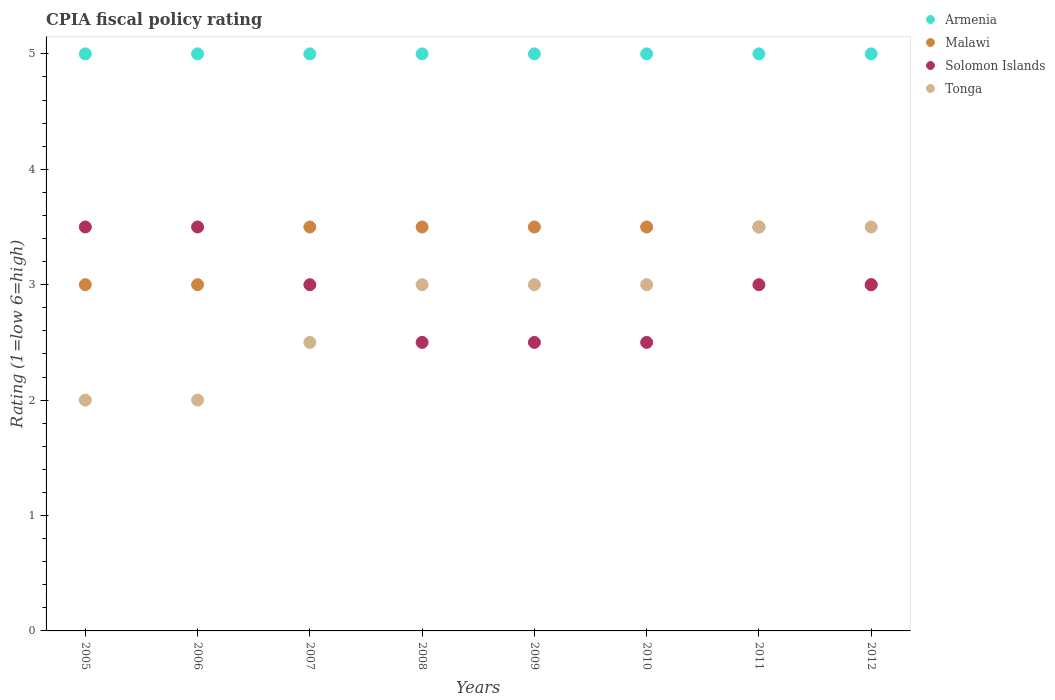What is the CPIA rating in Armenia in 2011?
Your response must be concise. 5. Across all years, what is the minimum CPIA rating in Malawi?
Give a very brief answer. 3. In which year was the CPIA rating in Malawi maximum?
Give a very brief answer. 2007. In which year was the CPIA rating in Armenia minimum?
Ensure brevity in your answer.  2005. What is the difference between the CPIA rating in Malawi in 2009 and the CPIA rating in Armenia in 2012?
Your answer should be compact. -1.5. What is the ratio of the CPIA rating in Malawi in 2008 to that in 2012?
Offer a terse response. 1.17. Is the CPIA rating in Tonga in 2005 less than that in 2011?
Give a very brief answer. Yes. What is the difference between the highest and the lowest CPIA rating in Armenia?
Give a very brief answer. 0. Is it the case that in every year, the sum of the CPIA rating in Solomon Islands and CPIA rating in Tonga  is greater than the CPIA rating in Malawi?
Keep it short and to the point. Yes. Does the CPIA rating in Armenia monotonically increase over the years?
Provide a short and direct response. No. Is the CPIA rating in Armenia strictly less than the CPIA rating in Malawi over the years?
Provide a short and direct response. No. Are the values on the major ticks of Y-axis written in scientific E-notation?
Provide a succinct answer. No. How many legend labels are there?
Make the answer very short. 4. What is the title of the graph?
Make the answer very short. CPIA fiscal policy rating. Does "Bangladesh" appear as one of the legend labels in the graph?
Your answer should be compact. No. What is the label or title of the X-axis?
Give a very brief answer. Years. What is the label or title of the Y-axis?
Offer a very short reply. Rating (1=low 6=high). What is the Rating (1=low 6=high) of Armenia in 2005?
Ensure brevity in your answer.  5. What is the Rating (1=low 6=high) in Malawi in 2005?
Ensure brevity in your answer.  3. What is the Rating (1=low 6=high) in Solomon Islands in 2005?
Your answer should be compact. 3.5. What is the Rating (1=low 6=high) of Tonga in 2005?
Your response must be concise. 2. What is the Rating (1=low 6=high) in Armenia in 2006?
Keep it short and to the point. 5. What is the Rating (1=low 6=high) in Solomon Islands in 2006?
Give a very brief answer. 3.5. What is the Rating (1=low 6=high) of Malawi in 2007?
Keep it short and to the point. 3.5. What is the Rating (1=low 6=high) in Tonga in 2007?
Your answer should be very brief. 2.5. What is the Rating (1=low 6=high) of Malawi in 2008?
Your response must be concise. 3.5. What is the Rating (1=low 6=high) in Solomon Islands in 2008?
Your answer should be compact. 2.5. What is the Rating (1=low 6=high) in Malawi in 2009?
Give a very brief answer. 3.5. What is the Rating (1=low 6=high) in Tonga in 2009?
Keep it short and to the point. 3. What is the Rating (1=low 6=high) in Malawi in 2010?
Your answer should be very brief. 3.5. What is the Rating (1=low 6=high) of Solomon Islands in 2011?
Your answer should be very brief. 3. What is the Rating (1=low 6=high) in Armenia in 2012?
Your response must be concise. 5. What is the Rating (1=low 6=high) in Malawi in 2012?
Offer a terse response. 3. What is the Rating (1=low 6=high) in Tonga in 2012?
Ensure brevity in your answer.  3.5. Across all years, what is the maximum Rating (1=low 6=high) in Malawi?
Provide a short and direct response. 3.5. Across all years, what is the maximum Rating (1=low 6=high) of Solomon Islands?
Offer a terse response. 3.5. Across all years, what is the minimum Rating (1=low 6=high) of Malawi?
Your response must be concise. 3. Across all years, what is the minimum Rating (1=low 6=high) in Solomon Islands?
Your response must be concise. 2.5. What is the total Rating (1=low 6=high) in Tonga in the graph?
Your answer should be compact. 22.5. What is the difference between the Rating (1=low 6=high) of Armenia in 2005 and that in 2006?
Offer a terse response. 0. What is the difference between the Rating (1=low 6=high) of Malawi in 2005 and that in 2006?
Your answer should be compact. 0. What is the difference between the Rating (1=low 6=high) of Armenia in 2005 and that in 2007?
Provide a short and direct response. 0. What is the difference between the Rating (1=low 6=high) in Malawi in 2005 and that in 2007?
Provide a succinct answer. -0.5. What is the difference between the Rating (1=low 6=high) of Solomon Islands in 2005 and that in 2007?
Keep it short and to the point. 0.5. What is the difference between the Rating (1=low 6=high) in Tonga in 2005 and that in 2007?
Offer a very short reply. -0.5. What is the difference between the Rating (1=low 6=high) of Armenia in 2005 and that in 2008?
Offer a terse response. 0. What is the difference between the Rating (1=low 6=high) of Solomon Islands in 2005 and that in 2008?
Ensure brevity in your answer.  1. What is the difference between the Rating (1=low 6=high) of Malawi in 2005 and that in 2009?
Your response must be concise. -0.5. What is the difference between the Rating (1=low 6=high) of Armenia in 2005 and that in 2010?
Keep it short and to the point. 0. What is the difference between the Rating (1=low 6=high) of Armenia in 2005 and that in 2011?
Make the answer very short. 0. What is the difference between the Rating (1=low 6=high) in Malawi in 2005 and that in 2011?
Your answer should be very brief. -0.5. What is the difference between the Rating (1=low 6=high) in Solomon Islands in 2005 and that in 2011?
Offer a terse response. 0.5. What is the difference between the Rating (1=low 6=high) of Armenia in 2005 and that in 2012?
Offer a terse response. 0. What is the difference between the Rating (1=low 6=high) of Solomon Islands in 2005 and that in 2012?
Keep it short and to the point. 0.5. What is the difference between the Rating (1=low 6=high) in Tonga in 2005 and that in 2012?
Provide a short and direct response. -1.5. What is the difference between the Rating (1=low 6=high) of Malawi in 2006 and that in 2007?
Your response must be concise. -0.5. What is the difference between the Rating (1=low 6=high) of Tonga in 2006 and that in 2007?
Make the answer very short. -0.5. What is the difference between the Rating (1=low 6=high) of Armenia in 2006 and that in 2008?
Your response must be concise. 0. What is the difference between the Rating (1=low 6=high) in Malawi in 2006 and that in 2008?
Give a very brief answer. -0.5. What is the difference between the Rating (1=low 6=high) in Solomon Islands in 2006 and that in 2008?
Make the answer very short. 1. What is the difference between the Rating (1=low 6=high) of Tonga in 2006 and that in 2008?
Your answer should be compact. -1. What is the difference between the Rating (1=low 6=high) of Armenia in 2006 and that in 2009?
Provide a succinct answer. 0. What is the difference between the Rating (1=low 6=high) of Malawi in 2006 and that in 2009?
Provide a succinct answer. -0.5. What is the difference between the Rating (1=low 6=high) of Armenia in 2006 and that in 2010?
Your answer should be compact. 0. What is the difference between the Rating (1=low 6=high) in Malawi in 2006 and that in 2010?
Your response must be concise. -0.5. What is the difference between the Rating (1=low 6=high) of Tonga in 2006 and that in 2010?
Offer a terse response. -1. What is the difference between the Rating (1=low 6=high) of Malawi in 2006 and that in 2011?
Offer a very short reply. -0.5. What is the difference between the Rating (1=low 6=high) in Solomon Islands in 2006 and that in 2011?
Provide a short and direct response. 0.5. What is the difference between the Rating (1=low 6=high) of Armenia in 2006 and that in 2012?
Make the answer very short. 0. What is the difference between the Rating (1=low 6=high) in Armenia in 2007 and that in 2008?
Provide a short and direct response. 0. What is the difference between the Rating (1=low 6=high) in Malawi in 2007 and that in 2008?
Provide a short and direct response. 0. What is the difference between the Rating (1=low 6=high) of Armenia in 2007 and that in 2009?
Keep it short and to the point. 0. What is the difference between the Rating (1=low 6=high) in Malawi in 2007 and that in 2009?
Provide a succinct answer. 0. What is the difference between the Rating (1=low 6=high) in Solomon Islands in 2007 and that in 2009?
Your response must be concise. 0.5. What is the difference between the Rating (1=low 6=high) of Malawi in 2007 and that in 2010?
Your response must be concise. 0. What is the difference between the Rating (1=low 6=high) in Solomon Islands in 2007 and that in 2010?
Provide a succinct answer. 0.5. What is the difference between the Rating (1=low 6=high) in Armenia in 2007 and that in 2011?
Provide a succinct answer. 0. What is the difference between the Rating (1=low 6=high) of Malawi in 2007 and that in 2011?
Your answer should be very brief. 0. What is the difference between the Rating (1=low 6=high) in Tonga in 2007 and that in 2011?
Give a very brief answer. -1. What is the difference between the Rating (1=low 6=high) in Solomon Islands in 2007 and that in 2012?
Offer a terse response. 0. What is the difference between the Rating (1=low 6=high) of Tonga in 2007 and that in 2012?
Make the answer very short. -1. What is the difference between the Rating (1=low 6=high) of Malawi in 2008 and that in 2009?
Your answer should be compact. 0. What is the difference between the Rating (1=low 6=high) of Tonga in 2008 and that in 2009?
Your answer should be very brief. 0. What is the difference between the Rating (1=low 6=high) of Armenia in 2008 and that in 2010?
Your answer should be very brief. 0. What is the difference between the Rating (1=low 6=high) of Malawi in 2008 and that in 2010?
Ensure brevity in your answer.  0. What is the difference between the Rating (1=low 6=high) in Tonga in 2008 and that in 2010?
Offer a very short reply. 0. What is the difference between the Rating (1=low 6=high) in Solomon Islands in 2008 and that in 2011?
Ensure brevity in your answer.  -0.5. What is the difference between the Rating (1=low 6=high) of Armenia in 2008 and that in 2012?
Offer a very short reply. 0. What is the difference between the Rating (1=low 6=high) in Malawi in 2008 and that in 2012?
Make the answer very short. 0.5. What is the difference between the Rating (1=low 6=high) in Tonga in 2008 and that in 2012?
Offer a very short reply. -0.5. What is the difference between the Rating (1=low 6=high) of Solomon Islands in 2009 and that in 2010?
Your answer should be very brief. 0. What is the difference between the Rating (1=low 6=high) of Armenia in 2009 and that in 2011?
Your answer should be very brief. 0. What is the difference between the Rating (1=low 6=high) of Malawi in 2009 and that in 2011?
Your response must be concise. 0. What is the difference between the Rating (1=low 6=high) of Solomon Islands in 2009 and that in 2012?
Give a very brief answer. -0.5. What is the difference between the Rating (1=low 6=high) of Armenia in 2010 and that in 2011?
Your response must be concise. 0. What is the difference between the Rating (1=low 6=high) in Malawi in 2010 and that in 2011?
Provide a short and direct response. 0. What is the difference between the Rating (1=low 6=high) of Armenia in 2010 and that in 2012?
Offer a very short reply. 0. What is the difference between the Rating (1=low 6=high) of Malawi in 2010 and that in 2012?
Your response must be concise. 0.5. What is the difference between the Rating (1=low 6=high) in Solomon Islands in 2010 and that in 2012?
Your response must be concise. -0.5. What is the difference between the Rating (1=low 6=high) of Malawi in 2011 and that in 2012?
Provide a succinct answer. 0.5. What is the difference between the Rating (1=low 6=high) in Solomon Islands in 2011 and that in 2012?
Ensure brevity in your answer.  0. What is the difference between the Rating (1=low 6=high) in Tonga in 2011 and that in 2012?
Give a very brief answer. 0. What is the difference between the Rating (1=low 6=high) of Armenia in 2005 and the Rating (1=low 6=high) of Malawi in 2006?
Keep it short and to the point. 2. What is the difference between the Rating (1=low 6=high) of Armenia in 2005 and the Rating (1=low 6=high) of Tonga in 2006?
Provide a short and direct response. 3. What is the difference between the Rating (1=low 6=high) in Armenia in 2005 and the Rating (1=low 6=high) in Malawi in 2007?
Provide a short and direct response. 1.5. What is the difference between the Rating (1=low 6=high) of Armenia in 2005 and the Rating (1=low 6=high) of Solomon Islands in 2007?
Your response must be concise. 2. What is the difference between the Rating (1=low 6=high) in Solomon Islands in 2005 and the Rating (1=low 6=high) in Tonga in 2007?
Make the answer very short. 1. What is the difference between the Rating (1=low 6=high) in Armenia in 2005 and the Rating (1=low 6=high) in Solomon Islands in 2008?
Your answer should be very brief. 2.5. What is the difference between the Rating (1=low 6=high) in Armenia in 2005 and the Rating (1=low 6=high) in Tonga in 2008?
Your response must be concise. 2. What is the difference between the Rating (1=low 6=high) of Malawi in 2005 and the Rating (1=low 6=high) of Solomon Islands in 2008?
Give a very brief answer. 0.5. What is the difference between the Rating (1=low 6=high) in Armenia in 2005 and the Rating (1=low 6=high) in Malawi in 2009?
Your answer should be compact. 1.5. What is the difference between the Rating (1=low 6=high) of Armenia in 2005 and the Rating (1=low 6=high) of Solomon Islands in 2009?
Your response must be concise. 2.5. What is the difference between the Rating (1=low 6=high) of Armenia in 2005 and the Rating (1=low 6=high) of Tonga in 2009?
Give a very brief answer. 2. What is the difference between the Rating (1=low 6=high) of Armenia in 2005 and the Rating (1=low 6=high) of Solomon Islands in 2010?
Provide a short and direct response. 2.5. What is the difference between the Rating (1=low 6=high) of Armenia in 2005 and the Rating (1=low 6=high) of Tonga in 2010?
Provide a short and direct response. 2. What is the difference between the Rating (1=low 6=high) in Armenia in 2005 and the Rating (1=low 6=high) in Tonga in 2011?
Offer a very short reply. 1.5. What is the difference between the Rating (1=low 6=high) of Malawi in 2005 and the Rating (1=low 6=high) of Solomon Islands in 2011?
Give a very brief answer. 0. What is the difference between the Rating (1=low 6=high) of Malawi in 2005 and the Rating (1=low 6=high) of Tonga in 2011?
Offer a terse response. -0.5. What is the difference between the Rating (1=low 6=high) of Armenia in 2005 and the Rating (1=low 6=high) of Malawi in 2012?
Provide a succinct answer. 2. What is the difference between the Rating (1=low 6=high) in Malawi in 2005 and the Rating (1=low 6=high) in Solomon Islands in 2012?
Offer a terse response. 0. What is the difference between the Rating (1=low 6=high) of Malawi in 2005 and the Rating (1=low 6=high) of Tonga in 2012?
Provide a short and direct response. -0.5. What is the difference between the Rating (1=low 6=high) in Solomon Islands in 2005 and the Rating (1=low 6=high) in Tonga in 2012?
Offer a terse response. 0. What is the difference between the Rating (1=low 6=high) in Armenia in 2006 and the Rating (1=low 6=high) in Malawi in 2007?
Your response must be concise. 1.5. What is the difference between the Rating (1=low 6=high) in Malawi in 2006 and the Rating (1=low 6=high) in Solomon Islands in 2007?
Ensure brevity in your answer.  0. What is the difference between the Rating (1=low 6=high) in Malawi in 2006 and the Rating (1=low 6=high) in Tonga in 2008?
Provide a short and direct response. 0. What is the difference between the Rating (1=low 6=high) of Armenia in 2006 and the Rating (1=low 6=high) of Malawi in 2009?
Keep it short and to the point. 1.5. What is the difference between the Rating (1=low 6=high) of Armenia in 2006 and the Rating (1=low 6=high) of Solomon Islands in 2009?
Offer a very short reply. 2.5. What is the difference between the Rating (1=low 6=high) of Armenia in 2006 and the Rating (1=low 6=high) of Tonga in 2009?
Ensure brevity in your answer.  2. What is the difference between the Rating (1=low 6=high) of Armenia in 2006 and the Rating (1=low 6=high) of Malawi in 2010?
Provide a short and direct response. 1.5. What is the difference between the Rating (1=low 6=high) of Armenia in 2006 and the Rating (1=low 6=high) of Solomon Islands in 2010?
Give a very brief answer. 2.5. What is the difference between the Rating (1=low 6=high) of Solomon Islands in 2006 and the Rating (1=low 6=high) of Tonga in 2010?
Offer a very short reply. 0.5. What is the difference between the Rating (1=low 6=high) in Armenia in 2006 and the Rating (1=low 6=high) in Malawi in 2011?
Ensure brevity in your answer.  1.5. What is the difference between the Rating (1=low 6=high) in Armenia in 2006 and the Rating (1=low 6=high) in Solomon Islands in 2011?
Your answer should be very brief. 2. What is the difference between the Rating (1=low 6=high) of Malawi in 2006 and the Rating (1=low 6=high) of Solomon Islands in 2011?
Your response must be concise. 0. What is the difference between the Rating (1=low 6=high) in Malawi in 2006 and the Rating (1=low 6=high) in Tonga in 2011?
Keep it short and to the point. -0.5. What is the difference between the Rating (1=low 6=high) of Solomon Islands in 2006 and the Rating (1=low 6=high) of Tonga in 2011?
Make the answer very short. 0. What is the difference between the Rating (1=low 6=high) in Armenia in 2006 and the Rating (1=low 6=high) in Malawi in 2012?
Your answer should be compact. 2. What is the difference between the Rating (1=low 6=high) of Armenia in 2007 and the Rating (1=low 6=high) of Malawi in 2008?
Make the answer very short. 1.5. What is the difference between the Rating (1=low 6=high) of Armenia in 2007 and the Rating (1=low 6=high) of Solomon Islands in 2008?
Your response must be concise. 2.5. What is the difference between the Rating (1=low 6=high) in Solomon Islands in 2007 and the Rating (1=low 6=high) in Tonga in 2008?
Give a very brief answer. 0. What is the difference between the Rating (1=low 6=high) in Armenia in 2007 and the Rating (1=low 6=high) in Solomon Islands in 2009?
Keep it short and to the point. 2.5. What is the difference between the Rating (1=low 6=high) of Solomon Islands in 2007 and the Rating (1=low 6=high) of Tonga in 2009?
Offer a terse response. 0. What is the difference between the Rating (1=low 6=high) of Armenia in 2007 and the Rating (1=low 6=high) of Malawi in 2010?
Your response must be concise. 1.5. What is the difference between the Rating (1=low 6=high) in Malawi in 2007 and the Rating (1=low 6=high) in Solomon Islands in 2010?
Give a very brief answer. 1. What is the difference between the Rating (1=low 6=high) of Malawi in 2007 and the Rating (1=low 6=high) of Tonga in 2010?
Offer a very short reply. 0.5. What is the difference between the Rating (1=low 6=high) in Solomon Islands in 2007 and the Rating (1=low 6=high) in Tonga in 2010?
Offer a terse response. 0. What is the difference between the Rating (1=low 6=high) of Armenia in 2007 and the Rating (1=low 6=high) of Tonga in 2011?
Your answer should be compact. 1.5. What is the difference between the Rating (1=low 6=high) in Malawi in 2007 and the Rating (1=low 6=high) in Tonga in 2011?
Make the answer very short. 0. What is the difference between the Rating (1=low 6=high) of Solomon Islands in 2007 and the Rating (1=low 6=high) of Tonga in 2011?
Your answer should be compact. -0.5. What is the difference between the Rating (1=low 6=high) in Armenia in 2007 and the Rating (1=low 6=high) in Solomon Islands in 2012?
Your answer should be very brief. 2. What is the difference between the Rating (1=low 6=high) of Armenia in 2007 and the Rating (1=low 6=high) of Tonga in 2012?
Make the answer very short. 1.5. What is the difference between the Rating (1=low 6=high) in Malawi in 2007 and the Rating (1=low 6=high) in Solomon Islands in 2012?
Make the answer very short. 0.5. What is the difference between the Rating (1=low 6=high) in Malawi in 2007 and the Rating (1=low 6=high) in Tonga in 2012?
Provide a short and direct response. 0. What is the difference between the Rating (1=low 6=high) in Solomon Islands in 2007 and the Rating (1=low 6=high) in Tonga in 2012?
Give a very brief answer. -0.5. What is the difference between the Rating (1=low 6=high) of Armenia in 2008 and the Rating (1=low 6=high) of Malawi in 2009?
Offer a very short reply. 1.5. What is the difference between the Rating (1=low 6=high) of Malawi in 2008 and the Rating (1=low 6=high) of Tonga in 2009?
Keep it short and to the point. 0.5. What is the difference between the Rating (1=low 6=high) of Solomon Islands in 2008 and the Rating (1=low 6=high) of Tonga in 2009?
Give a very brief answer. -0.5. What is the difference between the Rating (1=low 6=high) of Armenia in 2008 and the Rating (1=low 6=high) of Malawi in 2010?
Keep it short and to the point. 1.5. What is the difference between the Rating (1=low 6=high) of Armenia in 2008 and the Rating (1=low 6=high) of Solomon Islands in 2010?
Your answer should be very brief. 2.5. What is the difference between the Rating (1=low 6=high) of Malawi in 2008 and the Rating (1=low 6=high) of Tonga in 2010?
Give a very brief answer. 0.5. What is the difference between the Rating (1=low 6=high) in Armenia in 2008 and the Rating (1=low 6=high) in Malawi in 2011?
Keep it short and to the point. 1.5. What is the difference between the Rating (1=low 6=high) of Malawi in 2008 and the Rating (1=low 6=high) of Tonga in 2011?
Offer a very short reply. 0. What is the difference between the Rating (1=low 6=high) in Solomon Islands in 2008 and the Rating (1=low 6=high) in Tonga in 2011?
Offer a very short reply. -1. What is the difference between the Rating (1=low 6=high) in Armenia in 2008 and the Rating (1=low 6=high) in Malawi in 2012?
Offer a terse response. 2. What is the difference between the Rating (1=low 6=high) of Armenia in 2008 and the Rating (1=low 6=high) of Tonga in 2012?
Your answer should be very brief. 1.5. What is the difference between the Rating (1=low 6=high) in Malawi in 2008 and the Rating (1=low 6=high) in Solomon Islands in 2012?
Your response must be concise. 0.5. What is the difference between the Rating (1=low 6=high) of Malawi in 2008 and the Rating (1=low 6=high) of Tonga in 2012?
Make the answer very short. 0. What is the difference between the Rating (1=low 6=high) of Solomon Islands in 2008 and the Rating (1=low 6=high) of Tonga in 2012?
Ensure brevity in your answer.  -1. What is the difference between the Rating (1=low 6=high) of Armenia in 2009 and the Rating (1=low 6=high) of Malawi in 2010?
Provide a short and direct response. 1.5. What is the difference between the Rating (1=low 6=high) of Armenia in 2009 and the Rating (1=low 6=high) of Solomon Islands in 2010?
Keep it short and to the point. 2.5. What is the difference between the Rating (1=low 6=high) in Armenia in 2009 and the Rating (1=low 6=high) in Tonga in 2010?
Keep it short and to the point. 2. What is the difference between the Rating (1=low 6=high) of Malawi in 2009 and the Rating (1=low 6=high) of Solomon Islands in 2010?
Offer a very short reply. 1. What is the difference between the Rating (1=low 6=high) in Malawi in 2009 and the Rating (1=low 6=high) in Tonga in 2010?
Offer a very short reply. 0.5. What is the difference between the Rating (1=low 6=high) in Armenia in 2009 and the Rating (1=low 6=high) in Solomon Islands in 2011?
Provide a succinct answer. 2. What is the difference between the Rating (1=low 6=high) in Armenia in 2009 and the Rating (1=low 6=high) in Tonga in 2011?
Give a very brief answer. 1.5. What is the difference between the Rating (1=low 6=high) of Malawi in 2009 and the Rating (1=low 6=high) of Tonga in 2011?
Ensure brevity in your answer.  0. What is the difference between the Rating (1=low 6=high) of Solomon Islands in 2009 and the Rating (1=low 6=high) of Tonga in 2011?
Offer a terse response. -1. What is the difference between the Rating (1=low 6=high) of Armenia in 2009 and the Rating (1=low 6=high) of Malawi in 2012?
Provide a succinct answer. 2. What is the difference between the Rating (1=low 6=high) of Solomon Islands in 2009 and the Rating (1=low 6=high) of Tonga in 2012?
Your response must be concise. -1. What is the difference between the Rating (1=low 6=high) in Armenia in 2010 and the Rating (1=low 6=high) in Tonga in 2011?
Provide a short and direct response. 1.5. What is the difference between the Rating (1=low 6=high) in Malawi in 2010 and the Rating (1=low 6=high) in Solomon Islands in 2011?
Keep it short and to the point. 0.5. What is the difference between the Rating (1=low 6=high) of Malawi in 2010 and the Rating (1=low 6=high) of Tonga in 2011?
Offer a very short reply. 0. What is the difference between the Rating (1=low 6=high) of Armenia in 2010 and the Rating (1=low 6=high) of Malawi in 2012?
Give a very brief answer. 2. What is the difference between the Rating (1=low 6=high) of Armenia in 2010 and the Rating (1=low 6=high) of Tonga in 2012?
Give a very brief answer. 1.5. What is the difference between the Rating (1=low 6=high) of Malawi in 2010 and the Rating (1=low 6=high) of Solomon Islands in 2012?
Your answer should be compact. 0.5. What is the difference between the Rating (1=low 6=high) in Malawi in 2010 and the Rating (1=low 6=high) in Tonga in 2012?
Give a very brief answer. 0. What is the difference between the Rating (1=low 6=high) in Solomon Islands in 2010 and the Rating (1=low 6=high) in Tonga in 2012?
Your answer should be very brief. -1. What is the difference between the Rating (1=low 6=high) of Armenia in 2011 and the Rating (1=low 6=high) of Tonga in 2012?
Offer a terse response. 1.5. What is the difference between the Rating (1=low 6=high) of Malawi in 2011 and the Rating (1=low 6=high) of Tonga in 2012?
Your answer should be very brief. 0. What is the average Rating (1=low 6=high) in Armenia per year?
Keep it short and to the point. 5. What is the average Rating (1=low 6=high) in Malawi per year?
Provide a succinct answer. 3.31. What is the average Rating (1=low 6=high) of Solomon Islands per year?
Ensure brevity in your answer.  2.94. What is the average Rating (1=low 6=high) in Tonga per year?
Your answer should be compact. 2.81. In the year 2005, what is the difference between the Rating (1=low 6=high) in Armenia and Rating (1=low 6=high) in Malawi?
Make the answer very short. 2. In the year 2005, what is the difference between the Rating (1=low 6=high) in Armenia and Rating (1=low 6=high) in Solomon Islands?
Offer a very short reply. 1.5. In the year 2005, what is the difference between the Rating (1=low 6=high) in Armenia and Rating (1=low 6=high) in Tonga?
Your response must be concise. 3. In the year 2005, what is the difference between the Rating (1=low 6=high) in Solomon Islands and Rating (1=low 6=high) in Tonga?
Provide a succinct answer. 1.5. In the year 2006, what is the difference between the Rating (1=low 6=high) in Armenia and Rating (1=low 6=high) in Solomon Islands?
Ensure brevity in your answer.  1.5. In the year 2006, what is the difference between the Rating (1=low 6=high) of Solomon Islands and Rating (1=low 6=high) of Tonga?
Your answer should be very brief. 1.5. In the year 2007, what is the difference between the Rating (1=low 6=high) in Armenia and Rating (1=low 6=high) in Malawi?
Ensure brevity in your answer.  1.5. In the year 2007, what is the difference between the Rating (1=low 6=high) in Armenia and Rating (1=low 6=high) in Solomon Islands?
Provide a succinct answer. 2. In the year 2007, what is the difference between the Rating (1=low 6=high) in Solomon Islands and Rating (1=low 6=high) in Tonga?
Your answer should be compact. 0.5. In the year 2008, what is the difference between the Rating (1=low 6=high) of Malawi and Rating (1=low 6=high) of Solomon Islands?
Make the answer very short. 1. In the year 2008, what is the difference between the Rating (1=low 6=high) in Solomon Islands and Rating (1=low 6=high) in Tonga?
Offer a terse response. -0.5. In the year 2009, what is the difference between the Rating (1=low 6=high) in Armenia and Rating (1=low 6=high) in Malawi?
Ensure brevity in your answer.  1.5. In the year 2009, what is the difference between the Rating (1=low 6=high) of Malawi and Rating (1=low 6=high) of Solomon Islands?
Keep it short and to the point. 1. In the year 2009, what is the difference between the Rating (1=low 6=high) in Malawi and Rating (1=low 6=high) in Tonga?
Offer a terse response. 0.5. In the year 2009, what is the difference between the Rating (1=low 6=high) in Solomon Islands and Rating (1=low 6=high) in Tonga?
Your response must be concise. -0.5. In the year 2010, what is the difference between the Rating (1=low 6=high) of Armenia and Rating (1=low 6=high) of Malawi?
Provide a short and direct response. 1.5. In the year 2011, what is the difference between the Rating (1=low 6=high) in Armenia and Rating (1=low 6=high) in Malawi?
Offer a very short reply. 1.5. In the year 2011, what is the difference between the Rating (1=low 6=high) of Armenia and Rating (1=low 6=high) of Solomon Islands?
Ensure brevity in your answer.  2. In the year 2011, what is the difference between the Rating (1=low 6=high) of Armenia and Rating (1=low 6=high) of Tonga?
Give a very brief answer. 1.5. In the year 2011, what is the difference between the Rating (1=low 6=high) in Malawi and Rating (1=low 6=high) in Solomon Islands?
Your answer should be compact. 0.5. In the year 2012, what is the difference between the Rating (1=low 6=high) in Armenia and Rating (1=low 6=high) in Solomon Islands?
Ensure brevity in your answer.  2. In the year 2012, what is the difference between the Rating (1=low 6=high) of Armenia and Rating (1=low 6=high) of Tonga?
Ensure brevity in your answer.  1.5. What is the ratio of the Rating (1=low 6=high) of Armenia in 2005 to that in 2006?
Offer a very short reply. 1. What is the ratio of the Rating (1=low 6=high) in Solomon Islands in 2005 to that in 2006?
Your answer should be very brief. 1. What is the ratio of the Rating (1=low 6=high) of Tonga in 2005 to that in 2006?
Your response must be concise. 1. What is the ratio of the Rating (1=low 6=high) in Malawi in 2005 to that in 2007?
Give a very brief answer. 0.86. What is the ratio of the Rating (1=low 6=high) in Solomon Islands in 2005 to that in 2007?
Ensure brevity in your answer.  1.17. What is the ratio of the Rating (1=low 6=high) in Malawi in 2005 to that in 2008?
Offer a very short reply. 0.86. What is the ratio of the Rating (1=low 6=high) in Tonga in 2005 to that in 2008?
Ensure brevity in your answer.  0.67. What is the ratio of the Rating (1=low 6=high) in Armenia in 2005 to that in 2009?
Offer a terse response. 1. What is the ratio of the Rating (1=low 6=high) of Armenia in 2005 to that in 2010?
Provide a short and direct response. 1. What is the ratio of the Rating (1=low 6=high) of Malawi in 2005 to that in 2010?
Keep it short and to the point. 0.86. What is the ratio of the Rating (1=low 6=high) in Solomon Islands in 2005 to that in 2010?
Your response must be concise. 1.4. What is the ratio of the Rating (1=low 6=high) of Tonga in 2005 to that in 2010?
Your response must be concise. 0.67. What is the ratio of the Rating (1=low 6=high) in Armenia in 2005 to that in 2011?
Your answer should be compact. 1. What is the ratio of the Rating (1=low 6=high) of Solomon Islands in 2005 to that in 2012?
Your answer should be very brief. 1.17. What is the ratio of the Rating (1=low 6=high) of Tonga in 2005 to that in 2012?
Make the answer very short. 0.57. What is the ratio of the Rating (1=low 6=high) of Malawi in 2006 to that in 2007?
Offer a terse response. 0.86. What is the ratio of the Rating (1=low 6=high) of Solomon Islands in 2006 to that in 2007?
Your response must be concise. 1.17. What is the ratio of the Rating (1=low 6=high) of Tonga in 2006 to that in 2007?
Your answer should be very brief. 0.8. What is the ratio of the Rating (1=low 6=high) in Armenia in 2006 to that in 2008?
Give a very brief answer. 1. What is the ratio of the Rating (1=low 6=high) of Solomon Islands in 2006 to that in 2008?
Give a very brief answer. 1.4. What is the ratio of the Rating (1=low 6=high) in Tonga in 2006 to that in 2008?
Give a very brief answer. 0.67. What is the ratio of the Rating (1=low 6=high) in Armenia in 2006 to that in 2009?
Give a very brief answer. 1. What is the ratio of the Rating (1=low 6=high) in Malawi in 2006 to that in 2009?
Your response must be concise. 0.86. What is the ratio of the Rating (1=low 6=high) of Tonga in 2006 to that in 2010?
Offer a terse response. 0.67. What is the ratio of the Rating (1=low 6=high) of Armenia in 2006 to that in 2011?
Offer a terse response. 1. What is the ratio of the Rating (1=low 6=high) in Malawi in 2006 to that in 2011?
Give a very brief answer. 0.86. What is the ratio of the Rating (1=low 6=high) of Armenia in 2006 to that in 2012?
Make the answer very short. 1. What is the ratio of the Rating (1=low 6=high) of Malawi in 2006 to that in 2012?
Provide a succinct answer. 1. What is the ratio of the Rating (1=low 6=high) of Armenia in 2007 to that in 2008?
Your response must be concise. 1. What is the ratio of the Rating (1=low 6=high) in Tonga in 2007 to that in 2008?
Your response must be concise. 0.83. What is the ratio of the Rating (1=low 6=high) in Armenia in 2007 to that in 2009?
Keep it short and to the point. 1. What is the ratio of the Rating (1=low 6=high) of Tonga in 2007 to that in 2009?
Your answer should be very brief. 0.83. What is the ratio of the Rating (1=low 6=high) of Armenia in 2007 to that in 2010?
Offer a very short reply. 1. What is the ratio of the Rating (1=low 6=high) of Tonga in 2007 to that in 2010?
Make the answer very short. 0.83. What is the ratio of the Rating (1=low 6=high) of Solomon Islands in 2007 to that in 2011?
Provide a short and direct response. 1. What is the ratio of the Rating (1=low 6=high) of Tonga in 2007 to that in 2011?
Offer a terse response. 0.71. What is the ratio of the Rating (1=low 6=high) of Armenia in 2007 to that in 2012?
Provide a short and direct response. 1. What is the ratio of the Rating (1=low 6=high) in Malawi in 2007 to that in 2012?
Your answer should be compact. 1.17. What is the ratio of the Rating (1=low 6=high) in Armenia in 2008 to that in 2009?
Your answer should be compact. 1. What is the ratio of the Rating (1=low 6=high) in Malawi in 2008 to that in 2009?
Your response must be concise. 1. What is the ratio of the Rating (1=low 6=high) in Solomon Islands in 2008 to that in 2009?
Make the answer very short. 1. What is the ratio of the Rating (1=low 6=high) in Tonga in 2008 to that in 2009?
Provide a short and direct response. 1. What is the ratio of the Rating (1=low 6=high) of Armenia in 2008 to that in 2010?
Offer a terse response. 1. What is the ratio of the Rating (1=low 6=high) in Malawi in 2008 to that in 2010?
Your answer should be very brief. 1. What is the ratio of the Rating (1=low 6=high) of Solomon Islands in 2008 to that in 2010?
Your response must be concise. 1. What is the ratio of the Rating (1=low 6=high) of Armenia in 2008 to that in 2011?
Offer a very short reply. 1. What is the ratio of the Rating (1=low 6=high) in Tonga in 2008 to that in 2011?
Give a very brief answer. 0.86. What is the ratio of the Rating (1=low 6=high) in Malawi in 2008 to that in 2012?
Offer a very short reply. 1.17. What is the ratio of the Rating (1=low 6=high) in Tonga in 2008 to that in 2012?
Offer a very short reply. 0.86. What is the ratio of the Rating (1=low 6=high) in Malawi in 2009 to that in 2010?
Your answer should be very brief. 1. What is the ratio of the Rating (1=low 6=high) in Solomon Islands in 2009 to that in 2010?
Provide a succinct answer. 1. What is the ratio of the Rating (1=low 6=high) in Armenia in 2009 to that in 2011?
Ensure brevity in your answer.  1. What is the ratio of the Rating (1=low 6=high) of Malawi in 2009 to that in 2011?
Your answer should be very brief. 1. What is the ratio of the Rating (1=low 6=high) of Solomon Islands in 2009 to that in 2011?
Make the answer very short. 0.83. What is the ratio of the Rating (1=low 6=high) in Tonga in 2010 to that in 2011?
Offer a terse response. 0.86. What is the ratio of the Rating (1=low 6=high) in Malawi in 2010 to that in 2012?
Offer a terse response. 1.17. What is the ratio of the Rating (1=low 6=high) of Solomon Islands in 2010 to that in 2012?
Make the answer very short. 0.83. What is the ratio of the Rating (1=low 6=high) in Tonga in 2010 to that in 2012?
Offer a terse response. 0.86. What is the ratio of the Rating (1=low 6=high) in Armenia in 2011 to that in 2012?
Offer a terse response. 1. What is the ratio of the Rating (1=low 6=high) of Solomon Islands in 2011 to that in 2012?
Make the answer very short. 1. What is the difference between the highest and the second highest Rating (1=low 6=high) of Armenia?
Offer a terse response. 0. What is the difference between the highest and the second highest Rating (1=low 6=high) of Malawi?
Give a very brief answer. 0. What is the difference between the highest and the second highest Rating (1=low 6=high) in Solomon Islands?
Your response must be concise. 0. What is the difference between the highest and the second highest Rating (1=low 6=high) of Tonga?
Your response must be concise. 0. What is the difference between the highest and the lowest Rating (1=low 6=high) in Malawi?
Offer a terse response. 0.5. What is the difference between the highest and the lowest Rating (1=low 6=high) in Tonga?
Your answer should be compact. 1.5. 